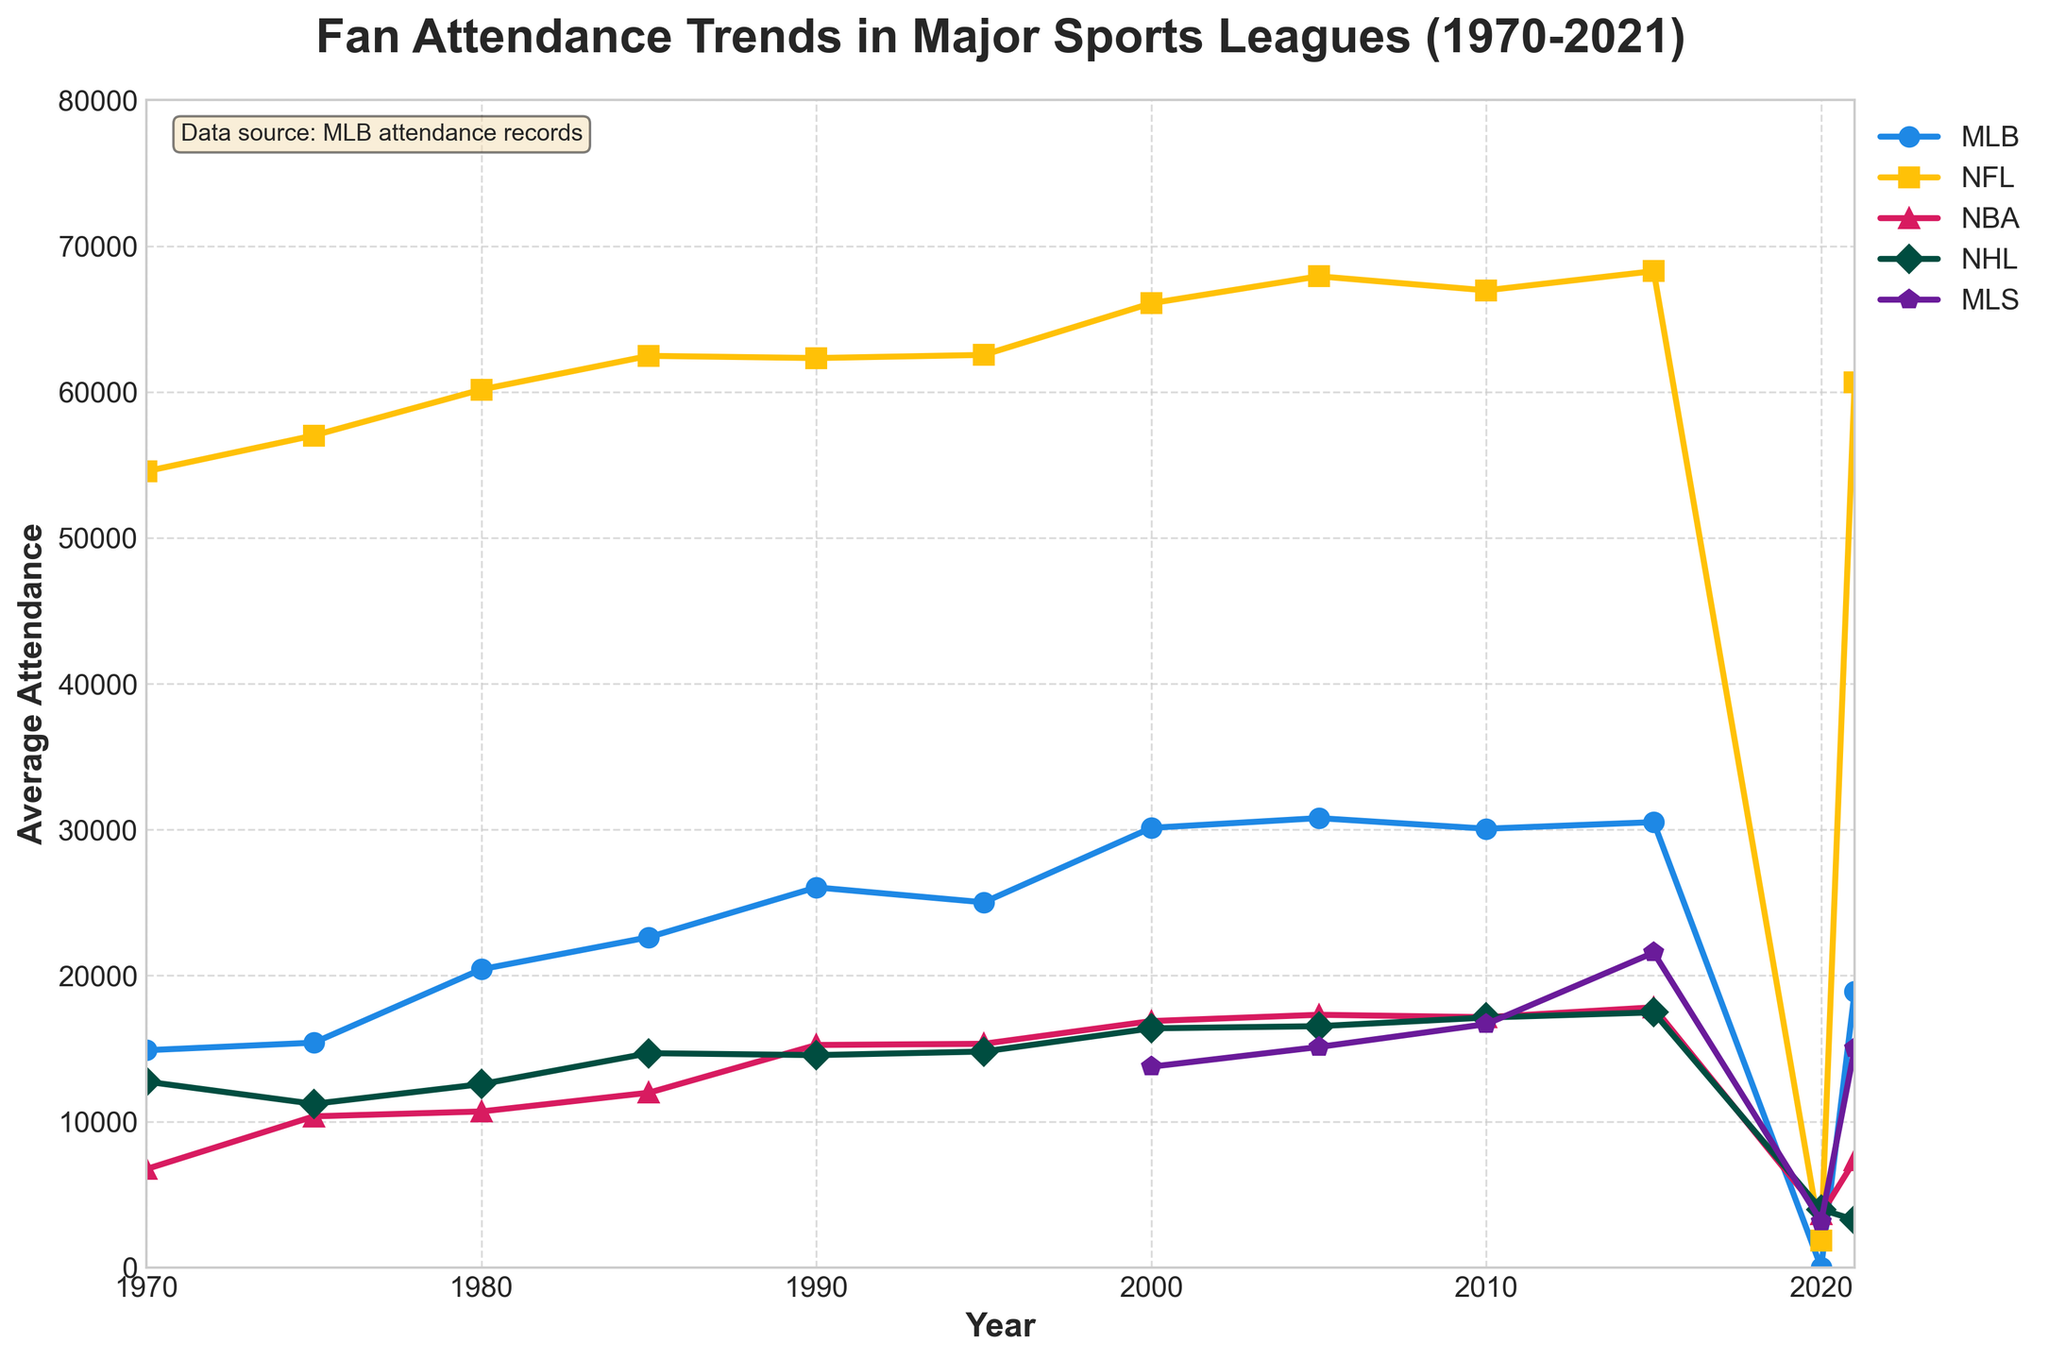Which sports league saw the highest average fan attendance in 2015? To find this, refer to the data points for the year 2015 and identify the highest value among the sports leagues. According to the figure, in 2015, the NFL saw the highest average fan attendance with a value of 68278.
Answer: NFL How did the average MLB attendance in 2000 compare to that in 1980? Check the MLB attendance figures for the years 2000 and 1980. In 2000, the average attendance was 30125, while in 1980, it was 20434. The difference is calculated by subtracting the 1980 value from the 2000 value: 30125 - 20434 = 9691.
Answer: 9691 higher What was the attendance trend for MLS from 2000 to 2021? Examine the MLS data points from 2000 to 2021: 13756 (2000), 15108 (2005), 16675 (2010), 21574 (2015), 3154 (2020), 15014 (2021). It increased from 2000 to 2015, showed a significant drop in 2020 due to the pandemic, and rose again in 2021.
Answer: Increased, dropped in 2020, rose in 2021 Which league had the lowest average attendance in 2020? Compare the values for each league in the year 2020. MLB had 0 (season canceled), NFL had 1848, NBA had 3640, NHL had 3978, and MLS had 3154. Therefore, MLB had the lowest average attendance in 2020.
Answer: MLB By how much did the NBA average attendance increase from 1970 to 2015? Look at the NBA attendance in 1970 (6742) and 2015 (17826). Subtract the 1970 figure from the 2015 figure: 17826 - 6742 = 11084. This indicates that the average attendance for NBA increased by 11084 from 1970 to 2015.
Answer: 11084 What was the trend for NFL attendance from 1970 to 2021? Observe the data points for the NFL from 1970 (54563) to 2021 (60657). NFL attendance steadily increased over the years, peaking around 2015 before slightly dropping by 2021. There was a significant drop in 2020 due to the pandemic.
Answer: Steady increase, peak, drop in 2020, slight recovery by 2021 What is the overall average attendance for MLB between 1970 and 2021? Sum the MLB values from 1970 (14885), 1975 (15403), 1980 (20434), 1985 (22630), 1990 (26045), 1995 (25022), 2000 (30125), 2005 (30793), 2010 (30067), 2015 (30517), 2020 (0), and 2021 (18901), then divide by the number of years (12). The sum is 259822, and the average is 259822 / 12 ≈ 21652.
Answer: 21652 Which league showed the most consistent attendance from 1970 to 2021? Comparing the variability of the attendance figures across the years for each league, NHL shows less fluctuation compared to others as the values are more narrowly ranged. For leagues like NFL and MLB, there's significant variability.
Answer: NHL What was the difference in NHL attendance between 1970 and 1990? Find NHL attendance for 1970 (12734) and 1990 (14550) and subtract the former from the latter: 14550 - 12734 = 1816. The attendance increased by 1816 over this period.
Answer: 1816 